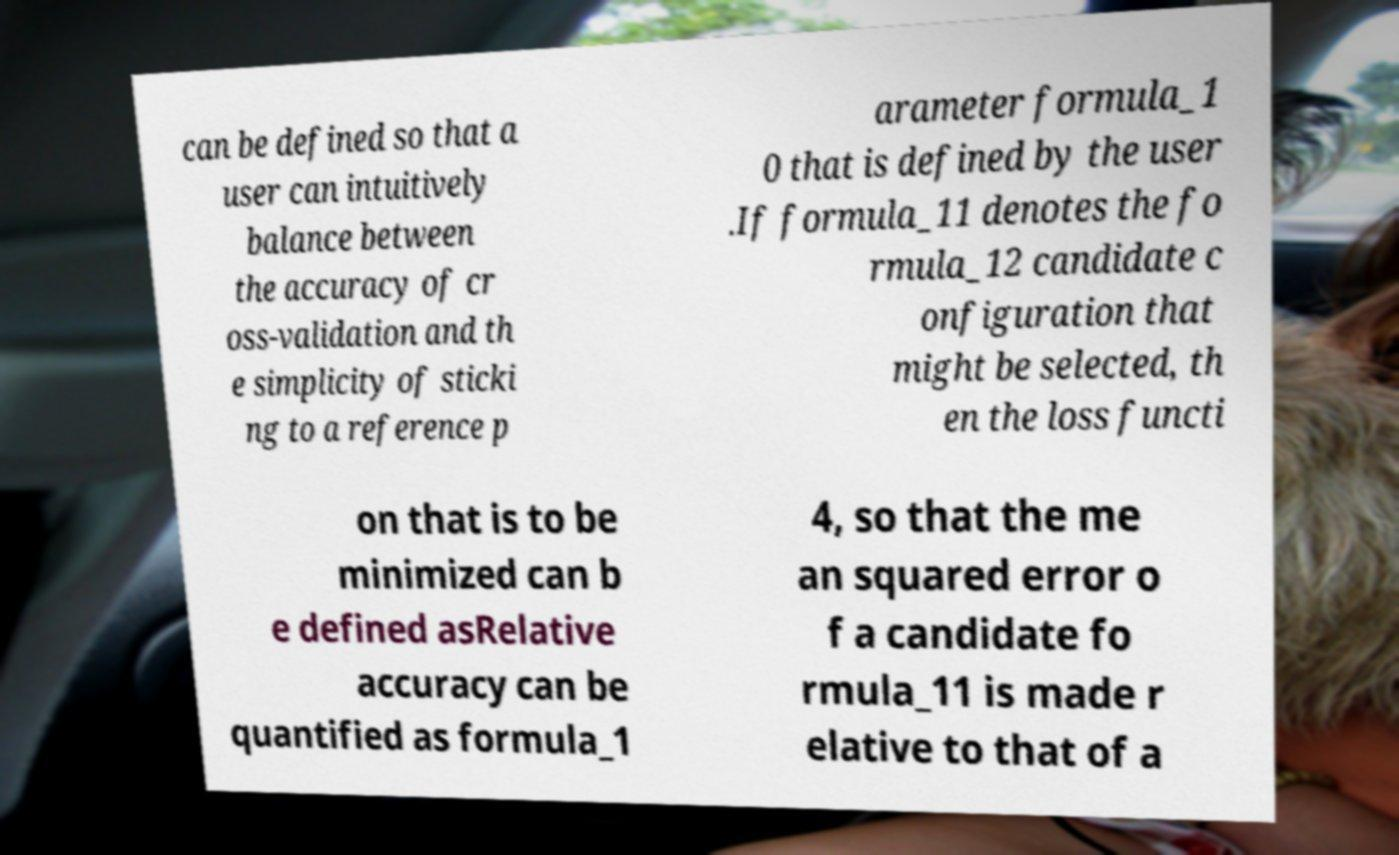What messages or text are displayed in this image? I need them in a readable, typed format. can be defined so that a user can intuitively balance between the accuracy of cr oss-validation and th e simplicity of sticki ng to a reference p arameter formula_1 0 that is defined by the user .If formula_11 denotes the fo rmula_12 candidate c onfiguration that might be selected, th en the loss functi on that is to be minimized can b e defined asRelative accuracy can be quantified as formula_1 4, so that the me an squared error o f a candidate fo rmula_11 is made r elative to that of a 